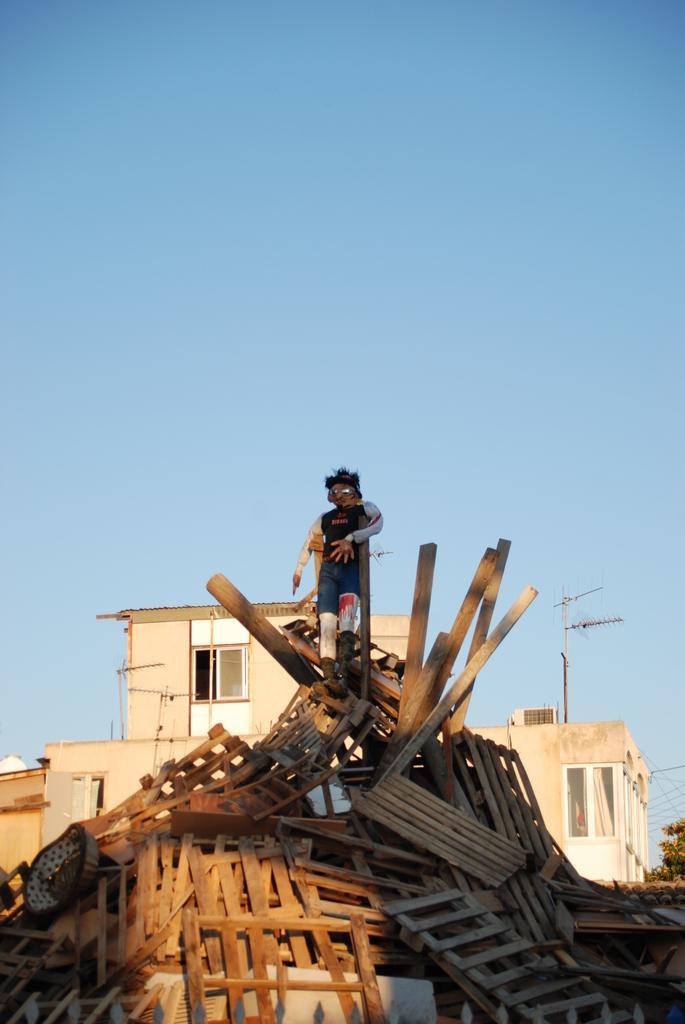Describe this image in one or two sentences. In this image I can see number of wooden objects which are brown in color and on them I can see a doll which is in the shape of a person. In the background I can see few buildings, few antennas, few trees and the sky. 